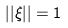<formula> <loc_0><loc_0><loc_500><loc_500>| | \xi | | = 1</formula> 